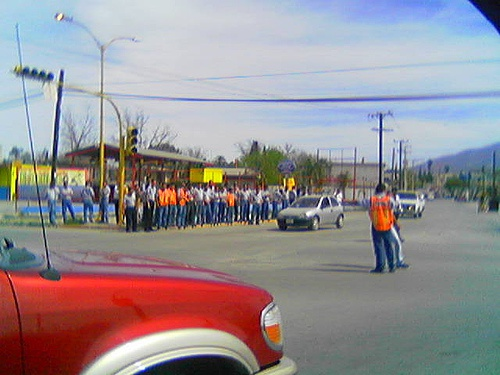Describe the objects in this image and their specific colors. I can see truck in lightblue, brown, red, maroon, and darkgray tones, car in lightblue, brown, red, maroon, and darkgray tones, people in lightblue, gray, black, darkgray, and navy tones, people in lightblue, navy, gray, darkgray, and red tones, and car in lightblue, darkgray, gray, black, and navy tones in this image. 